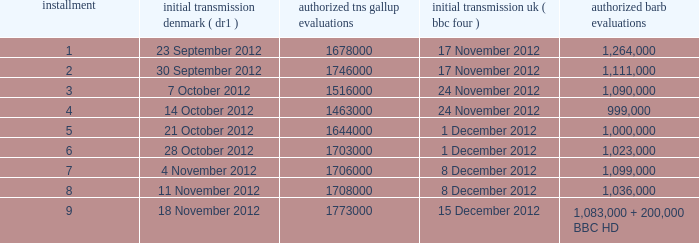When was the episode with a 999,000 BARB rating first aired in Denmark? 14 October 2012. 